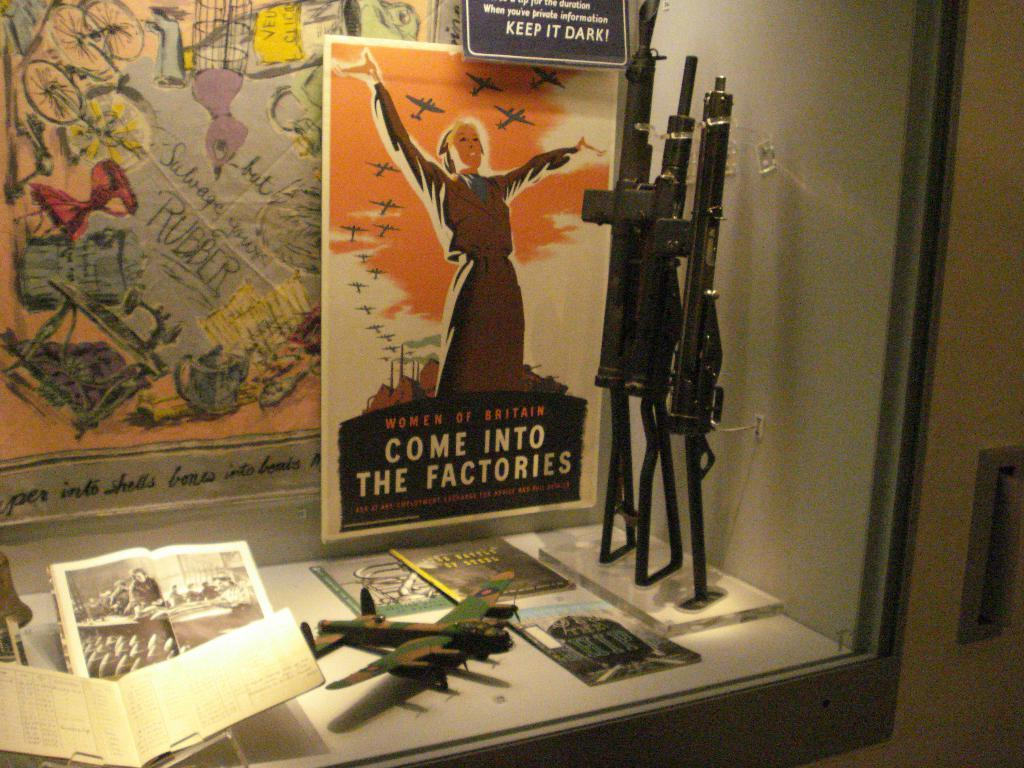<image>
Present a compact description of the photo's key features. A museum display of wartime items including a poster that says "Come into the factories". 